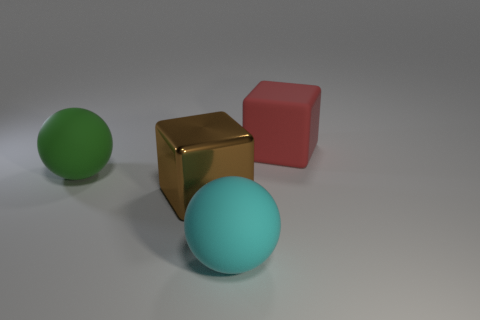There is a thing on the left side of the big shiny cube; is it the same shape as the matte object that is in front of the large green object?
Make the answer very short. Yes. How many big brown shiny things are behind the big cube that is in front of the block that is to the right of the cyan rubber sphere?
Keep it short and to the point. 0. The block in front of the large matte sphere to the left of the rubber object that is in front of the large green sphere is made of what material?
Ensure brevity in your answer.  Metal. Is the cube that is left of the large red thing made of the same material as the green sphere?
Give a very brief answer. No. How many brown shiny objects have the same size as the green rubber ball?
Your answer should be very brief. 1. Is the number of objects left of the red object greater than the number of large green balls to the right of the brown object?
Make the answer very short. Yes. Are there any large green matte things of the same shape as the red matte thing?
Your answer should be very brief. No. There is a rubber thing that is in front of the ball to the left of the big cyan thing; how big is it?
Offer a terse response. Large. There is a big rubber object that is left of the large cube that is to the left of the big cube that is on the right side of the large cyan rubber object; what shape is it?
Provide a succinct answer. Sphere. Are there more red rubber things than cyan matte cylinders?
Provide a short and direct response. Yes. 